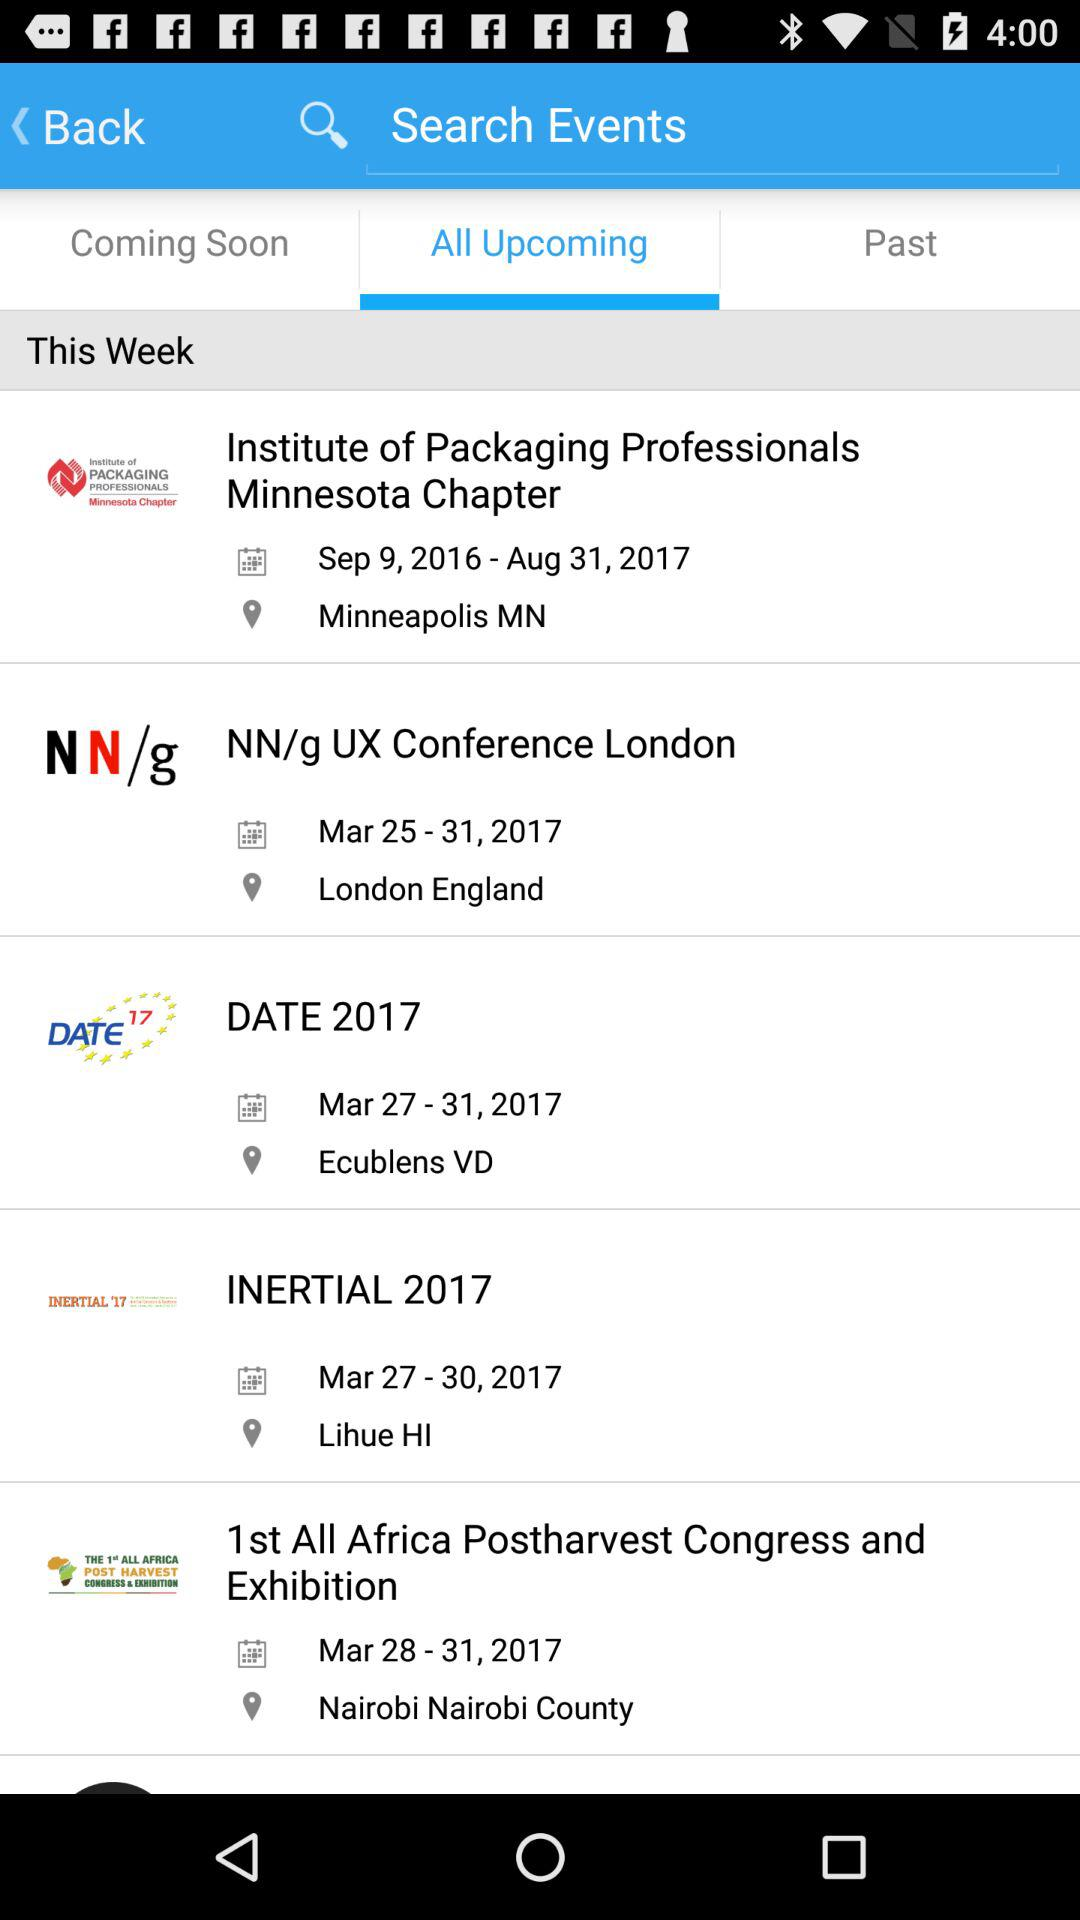What is the selected tab? The selected tab is "All Upcoming". 